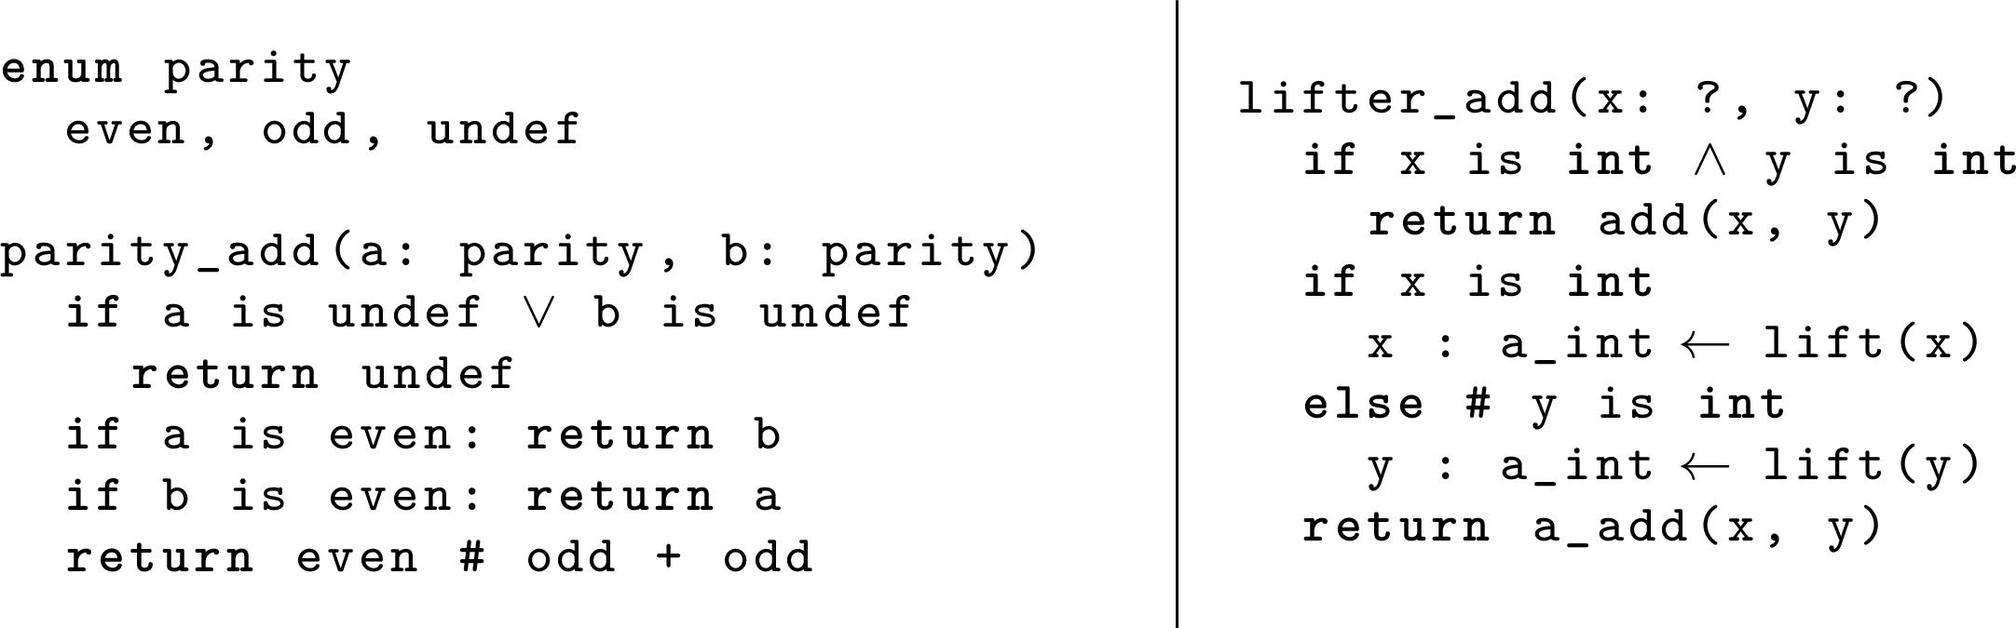What would be the result of `parity_add` if both `a` and `b` have the `even` parity? According to the function's code shown in the image, if both values `a` and `b` are categorized as `even`, the `parity_add` function also returns `even`. This maintains the closure property over addition within the set of even numbers. 